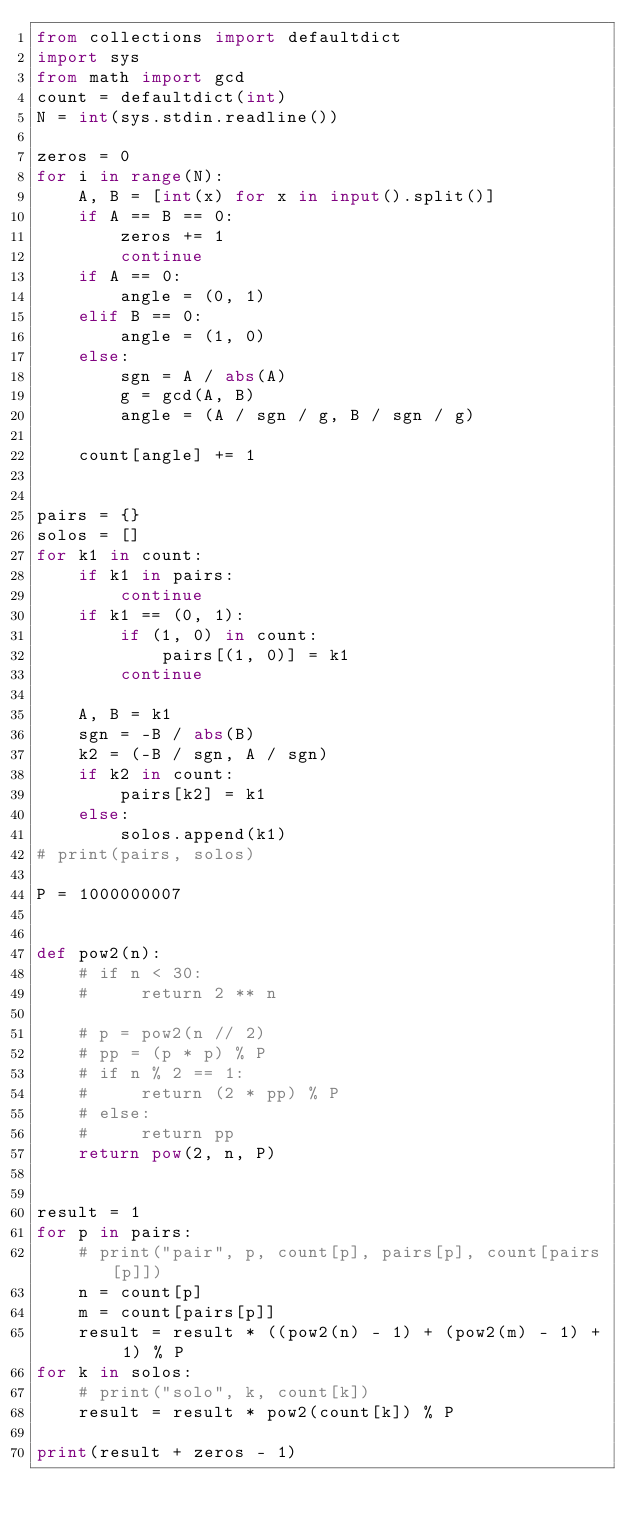<code> <loc_0><loc_0><loc_500><loc_500><_Python_>from collections import defaultdict
import sys
from math import gcd
count = defaultdict(int)
N = int(sys.stdin.readline())

zeros = 0
for i in range(N):
    A, B = [int(x) for x in input().split()]
    if A == B == 0:
        zeros += 1
        continue
    if A == 0:
        angle = (0, 1)
    elif B == 0:
        angle = (1, 0)
    else:
        sgn = A / abs(A)
        g = gcd(A, B)
        angle = (A / sgn / g, B / sgn / g)

    count[angle] += 1


pairs = {}
solos = []
for k1 in count:
    if k1 in pairs:
        continue
    if k1 == (0, 1):
        if (1, 0) in count:
            pairs[(1, 0)] = k1
        continue

    A, B = k1
    sgn = -B / abs(B)
    k2 = (-B / sgn, A / sgn)
    if k2 in count:
        pairs[k2] = k1
    else:
        solos.append(k1)
# print(pairs, solos)

P = 1000000007


def pow2(n):
    # if n < 30:
    #     return 2 ** n

    # p = pow2(n // 2)
    # pp = (p * p) % P
    # if n % 2 == 1:
    #     return (2 * pp) % P
    # else:
    #     return pp
    return pow(2, n, P)


result = 1
for p in pairs:
    # print("pair", p, count[p], pairs[p], count[pairs[p]])
    n = count[p]
    m = count[pairs[p]]
    result = result * ((pow2(n) - 1) + (pow2(m) - 1) + 1) % P
for k in solos:
    # print("solo", k, count[k])
    result = result * pow2(count[k]) % P

print(result + zeros - 1)
</code> 